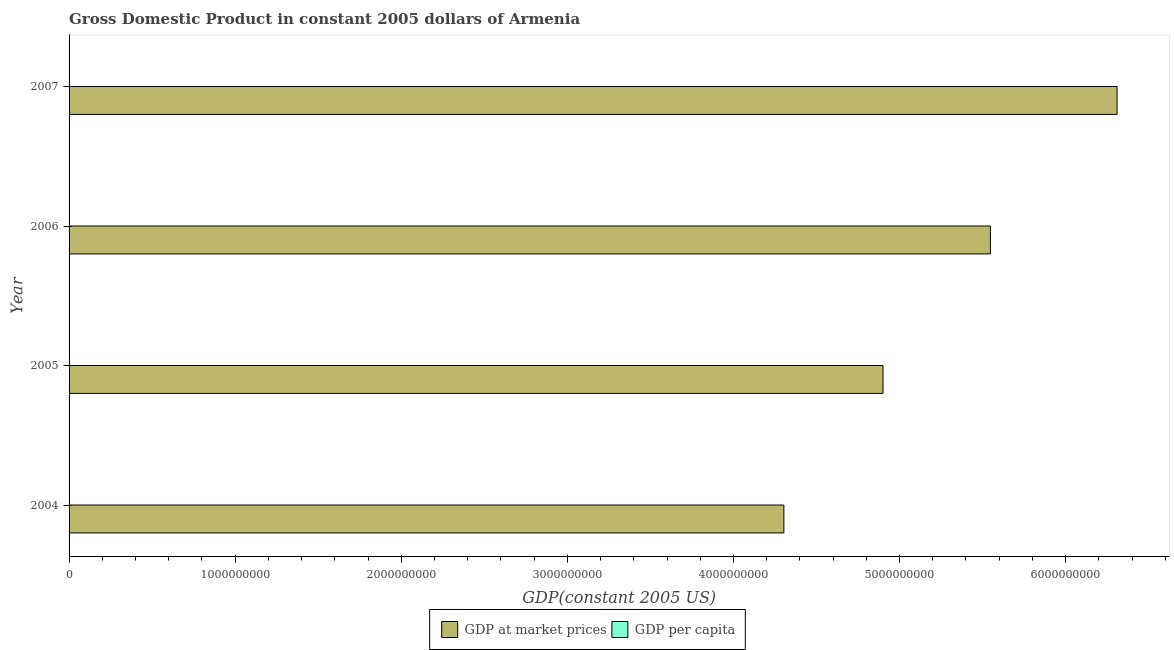How many different coloured bars are there?
Offer a very short reply. 2. How many groups of bars are there?
Offer a terse response. 4. What is the label of the 3rd group of bars from the top?
Make the answer very short. 2005. What is the gdp at market prices in 2007?
Make the answer very short. 6.31e+09. Across all years, what is the maximum gdp per capita?
Your response must be concise. 2111.68. Across all years, what is the minimum gdp at market prices?
Offer a very short reply. 4.30e+09. In which year was the gdp per capita maximum?
Your answer should be very brief. 2007. In which year was the gdp per capita minimum?
Keep it short and to the point. 2004. What is the total gdp at market prices in the graph?
Your response must be concise. 2.11e+1. What is the difference between the gdp at market prices in 2005 and that in 2007?
Offer a very short reply. -1.41e+09. What is the difference between the gdp per capita in 2004 and the gdp at market prices in 2006?
Give a very brief answer. -5.55e+09. What is the average gdp at market prices per year?
Provide a succinct answer. 5.27e+09. In the year 2007, what is the difference between the gdp at market prices and gdp per capita?
Provide a succinct answer. 6.31e+09. What is the ratio of the gdp at market prices in 2005 to that in 2007?
Give a very brief answer. 0.78. Is the difference between the gdp at market prices in 2004 and 2007 greater than the difference between the gdp per capita in 2004 and 2007?
Your response must be concise. No. What is the difference between the highest and the second highest gdp at market prices?
Your response must be concise. 7.63e+08. What is the difference between the highest and the lowest gdp per capita?
Offer a terse response. 689.42. What does the 2nd bar from the top in 2005 represents?
Offer a very short reply. GDP at market prices. What does the 1st bar from the bottom in 2007 represents?
Offer a terse response. GDP at market prices. How many bars are there?
Keep it short and to the point. 8. Are all the bars in the graph horizontal?
Ensure brevity in your answer.  Yes. How many years are there in the graph?
Give a very brief answer. 4. What is the difference between two consecutive major ticks on the X-axis?
Offer a terse response. 1.00e+09. Are the values on the major ticks of X-axis written in scientific E-notation?
Your answer should be very brief. No. Where does the legend appear in the graph?
Offer a very short reply. Bottom center. How are the legend labels stacked?
Make the answer very short. Horizontal. What is the title of the graph?
Your answer should be compact. Gross Domestic Product in constant 2005 dollars of Armenia. What is the label or title of the X-axis?
Offer a terse response. GDP(constant 2005 US). What is the GDP(constant 2005 US) of GDP at market prices in 2004?
Provide a short and direct response. 4.30e+09. What is the GDP(constant 2005 US) in GDP per capita in 2004?
Keep it short and to the point. 1422.26. What is the GDP(constant 2005 US) of GDP at market prices in 2005?
Provide a succinct answer. 4.90e+09. What is the GDP(constant 2005 US) in GDP per capita in 2005?
Make the answer very short. 1625.41. What is the GDP(constant 2005 US) in GDP at market prices in 2006?
Keep it short and to the point. 5.55e+09. What is the GDP(constant 2005 US) of GDP per capita in 2006?
Provide a short and direct response. 1847.75. What is the GDP(constant 2005 US) of GDP at market prices in 2007?
Ensure brevity in your answer.  6.31e+09. What is the GDP(constant 2005 US) of GDP per capita in 2007?
Your answer should be very brief. 2111.68. Across all years, what is the maximum GDP(constant 2005 US) in GDP at market prices?
Ensure brevity in your answer.  6.31e+09. Across all years, what is the maximum GDP(constant 2005 US) in GDP per capita?
Give a very brief answer. 2111.68. Across all years, what is the minimum GDP(constant 2005 US) of GDP at market prices?
Offer a very short reply. 4.30e+09. Across all years, what is the minimum GDP(constant 2005 US) in GDP per capita?
Your answer should be compact. 1422.26. What is the total GDP(constant 2005 US) of GDP at market prices in the graph?
Ensure brevity in your answer.  2.11e+1. What is the total GDP(constant 2005 US) in GDP per capita in the graph?
Keep it short and to the point. 7007.09. What is the difference between the GDP(constant 2005 US) of GDP at market prices in 2004 and that in 2005?
Keep it short and to the point. -5.97e+08. What is the difference between the GDP(constant 2005 US) of GDP per capita in 2004 and that in 2005?
Offer a very short reply. -203.15. What is the difference between the GDP(constant 2005 US) in GDP at market prices in 2004 and that in 2006?
Your answer should be compact. -1.24e+09. What is the difference between the GDP(constant 2005 US) of GDP per capita in 2004 and that in 2006?
Make the answer very short. -425.49. What is the difference between the GDP(constant 2005 US) of GDP at market prices in 2004 and that in 2007?
Offer a terse response. -2.01e+09. What is the difference between the GDP(constant 2005 US) of GDP per capita in 2004 and that in 2007?
Give a very brief answer. -689.42. What is the difference between the GDP(constant 2005 US) in GDP at market prices in 2005 and that in 2006?
Give a very brief answer. -6.47e+08. What is the difference between the GDP(constant 2005 US) in GDP per capita in 2005 and that in 2006?
Offer a very short reply. -222.34. What is the difference between the GDP(constant 2005 US) in GDP at market prices in 2005 and that in 2007?
Your response must be concise. -1.41e+09. What is the difference between the GDP(constant 2005 US) in GDP per capita in 2005 and that in 2007?
Offer a terse response. -486.27. What is the difference between the GDP(constant 2005 US) of GDP at market prices in 2006 and that in 2007?
Keep it short and to the point. -7.63e+08. What is the difference between the GDP(constant 2005 US) of GDP per capita in 2006 and that in 2007?
Make the answer very short. -263.93. What is the difference between the GDP(constant 2005 US) in GDP at market prices in 2004 and the GDP(constant 2005 US) in GDP per capita in 2005?
Your response must be concise. 4.30e+09. What is the difference between the GDP(constant 2005 US) in GDP at market prices in 2004 and the GDP(constant 2005 US) in GDP per capita in 2006?
Your answer should be compact. 4.30e+09. What is the difference between the GDP(constant 2005 US) in GDP at market prices in 2004 and the GDP(constant 2005 US) in GDP per capita in 2007?
Keep it short and to the point. 4.30e+09. What is the difference between the GDP(constant 2005 US) in GDP at market prices in 2005 and the GDP(constant 2005 US) in GDP per capita in 2006?
Keep it short and to the point. 4.90e+09. What is the difference between the GDP(constant 2005 US) of GDP at market prices in 2005 and the GDP(constant 2005 US) of GDP per capita in 2007?
Provide a succinct answer. 4.90e+09. What is the difference between the GDP(constant 2005 US) in GDP at market prices in 2006 and the GDP(constant 2005 US) in GDP per capita in 2007?
Offer a terse response. 5.55e+09. What is the average GDP(constant 2005 US) of GDP at market prices per year?
Your answer should be very brief. 5.27e+09. What is the average GDP(constant 2005 US) in GDP per capita per year?
Give a very brief answer. 1751.77. In the year 2004, what is the difference between the GDP(constant 2005 US) in GDP at market prices and GDP(constant 2005 US) in GDP per capita?
Your response must be concise. 4.30e+09. In the year 2005, what is the difference between the GDP(constant 2005 US) in GDP at market prices and GDP(constant 2005 US) in GDP per capita?
Keep it short and to the point. 4.90e+09. In the year 2006, what is the difference between the GDP(constant 2005 US) of GDP at market prices and GDP(constant 2005 US) of GDP per capita?
Make the answer very short. 5.55e+09. In the year 2007, what is the difference between the GDP(constant 2005 US) of GDP at market prices and GDP(constant 2005 US) of GDP per capita?
Your answer should be very brief. 6.31e+09. What is the ratio of the GDP(constant 2005 US) of GDP at market prices in 2004 to that in 2005?
Your answer should be compact. 0.88. What is the ratio of the GDP(constant 2005 US) in GDP at market prices in 2004 to that in 2006?
Your answer should be very brief. 0.78. What is the ratio of the GDP(constant 2005 US) in GDP per capita in 2004 to that in 2006?
Give a very brief answer. 0.77. What is the ratio of the GDP(constant 2005 US) in GDP at market prices in 2004 to that in 2007?
Offer a very short reply. 0.68. What is the ratio of the GDP(constant 2005 US) in GDP per capita in 2004 to that in 2007?
Make the answer very short. 0.67. What is the ratio of the GDP(constant 2005 US) in GDP at market prices in 2005 to that in 2006?
Your response must be concise. 0.88. What is the ratio of the GDP(constant 2005 US) in GDP per capita in 2005 to that in 2006?
Offer a very short reply. 0.88. What is the ratio of the GDP(constant 2005 US) of GDP at market prices in 2005 to that in 2007?
Offer a very short reply. 0.78. What is the ratio of the GDP(constant 2005 US) of GDP per capita in 2005 to that in 2007?
Keep it short and to the point. 0.77. What is the ratio of the GDP(constant 2005 US) of GDP at market prices in 2006 to that in 2007?
Offer a very short reply. 0.88. What is the difference between the highest and the second highest GDP(constant 2005 US) of GDP at market prices?
Offer a terse response. 7.63e+08. What is the difference between the highest and the second highest GDP(constant 2005 US) in GDP per capita?
Offer a very short reply. 263.93. What is the difference between the highest and the lowest GDP(constant 2005 US) in GDP at market prices?
Provide a succinct answer. 2.01e+09. What is the difference between the highest and the lowest GDP(constant 2005 US) of GDP per capita?
Your answer should be compact. 689.42. 